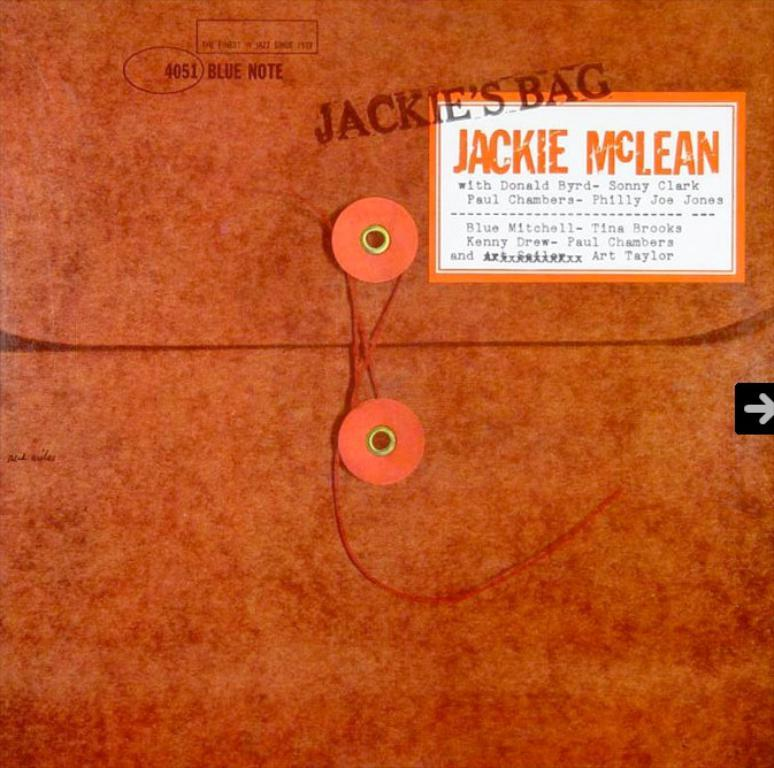Provide a one-sentence caption for the provided image. Jackie McLean left her personal documents on the desk. 